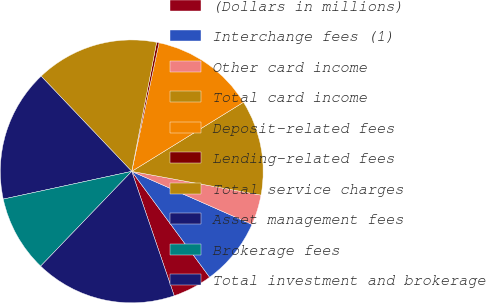Convert chart. <chart><loc_0><loc_0><loc_500><loc_500><pie_chart><fcel>(Dollars in millions)<fcel>Interchange fees (1)<fcel>Other card income<fcel>Total card income<fcel>Deposit-related fees<fcel>Lending-related fees<fcel>Total service charges<fcel>Asset management fees<fcel>Brokerage fees<fcel>Total investment and brokerage<nl><fcel>4.86%<fcel>8.29%<fcel>3.72%<fcel>11.71%<fcel>12.85%<fcel>0.3%<fcel>15.14%<fcel>16.28%<fcel>9.43%<fcel>17.42%<nl></chart> 